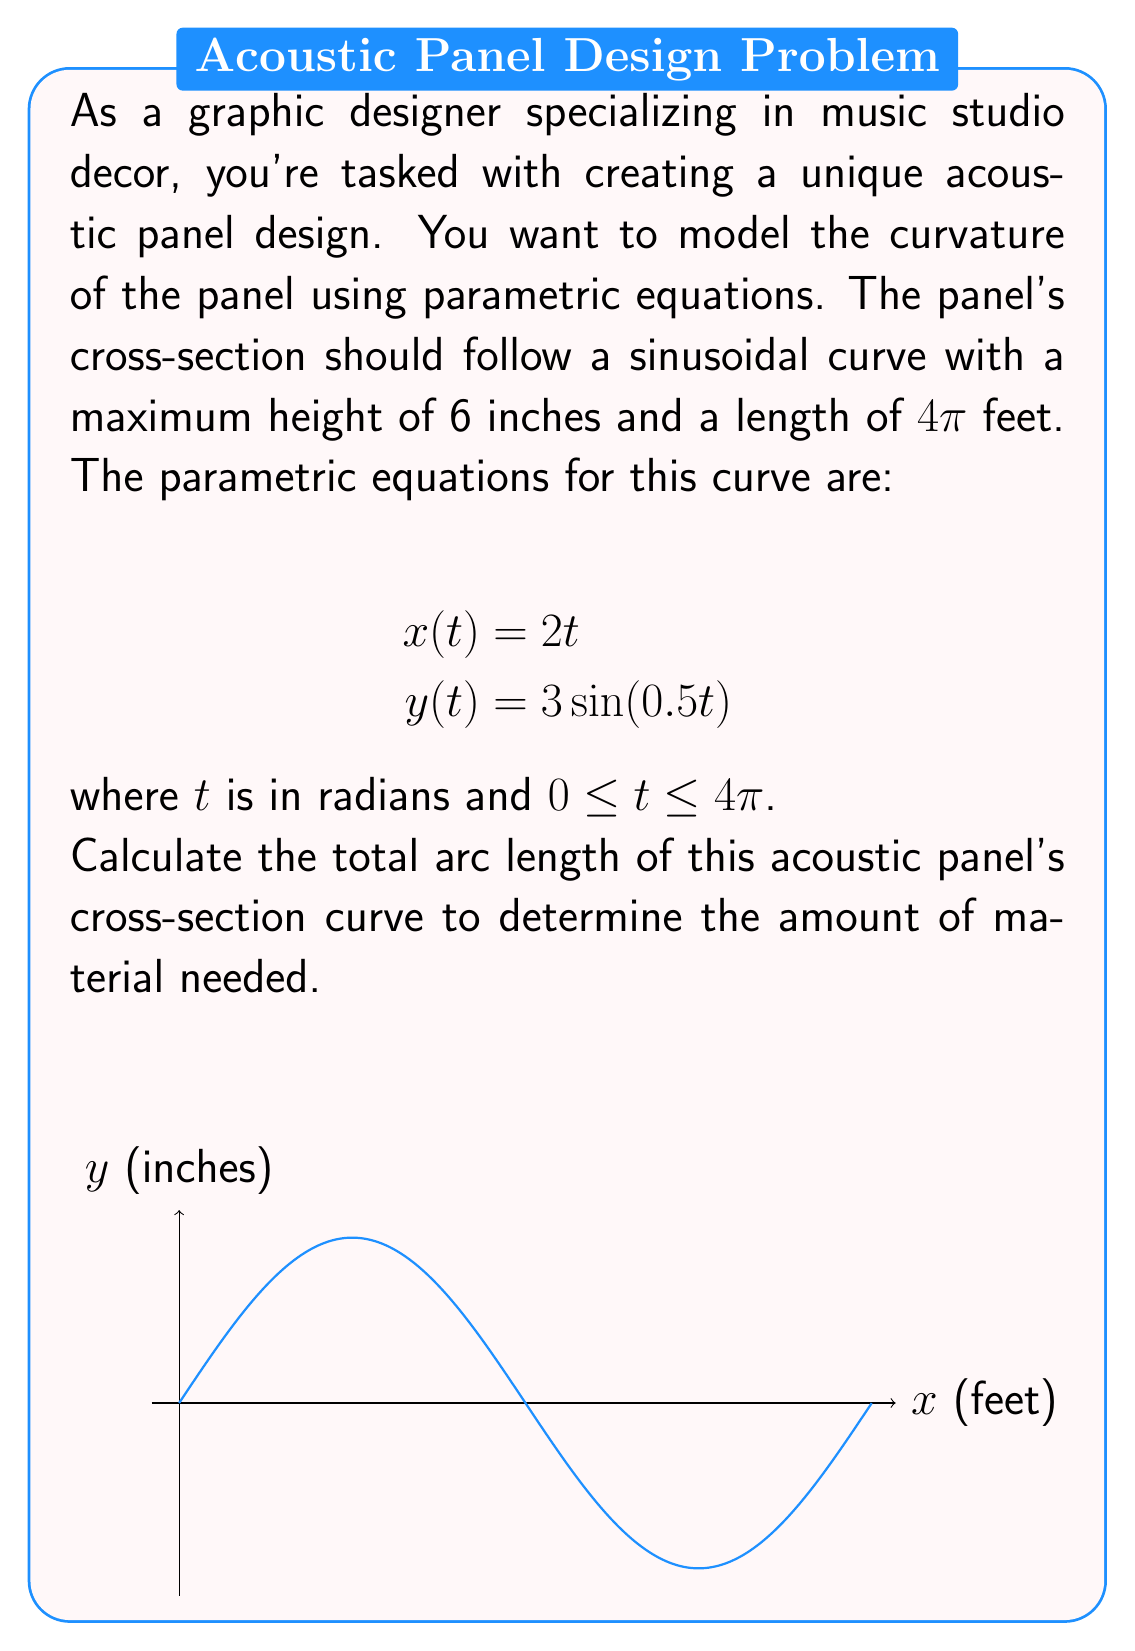Can you answer this question? To find the arc length of a parametric curve, we use the formula:

$$L = \int_{a}^{b} \sqrt{\left(\frac{dx}{dt}\right)^2 + \left(\frac{dy}{dt}\right)^2} dt$$

Step 1: Find $\frac{dx}{dt}$ and $\frac{dy}{dt}$
$$\frac{dx}{dt} = 2$$
$$\frac{dy}{dt} = 3 \cdot 0.5 \cos(0.5t) = 1.5\cos(0.5t)$$

Step 2: Substitute into the arc length formula
$$L = \int_{0}^{4\pi} \sqrt{2^2 + (1.5\cos(0.5t))^2} dt$$

Step 3: Simplify under the square root
$$L = \int_{0}^{4\pi} \sqrt{4 + 2.25\cos^2(0.5t)} dt$$

Step 4: This integral doesn't have an elementary antiderivative, so we need to use numerical integration. Using a computer algebra system or numerical integration tool, we get:

$$L \approx 25.13$$

Step 5: The result is in feet, as x was measured in feet in the original equations.
Answer: $25.13$ feet 